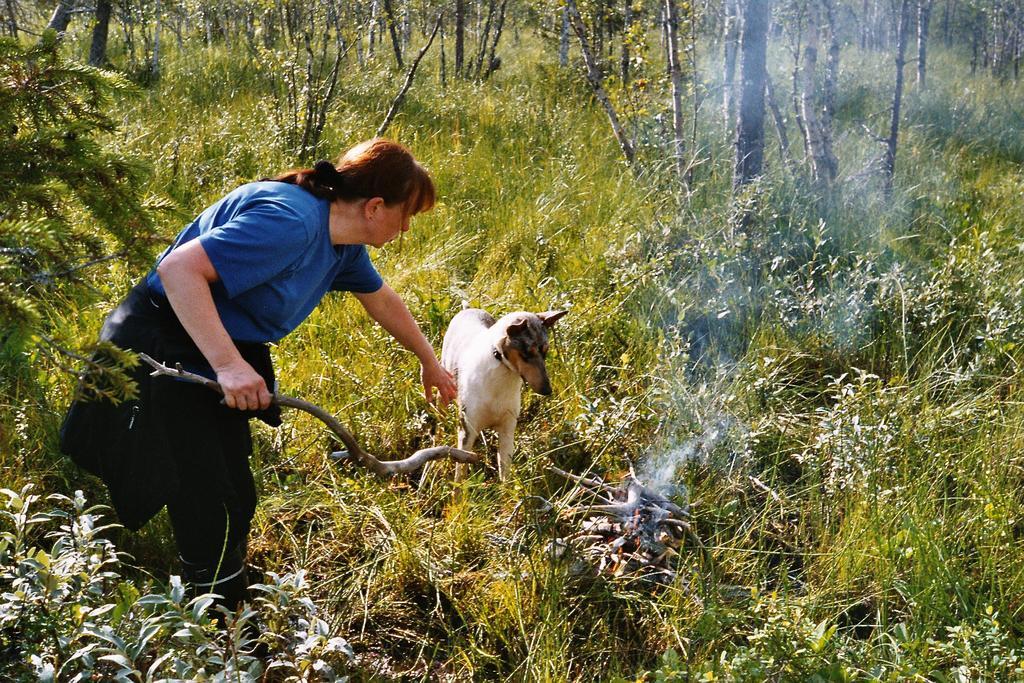Can you describe this image briefly? In this image we can see a lady holding a stick. There is a dog. At the bottom of the image there is grass, plants. In the background of the image there are trees. 